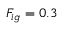<formula> <loc_0><loc_0><loc_500><loc_500>F _ { i g } = 0 . 3</formula> 